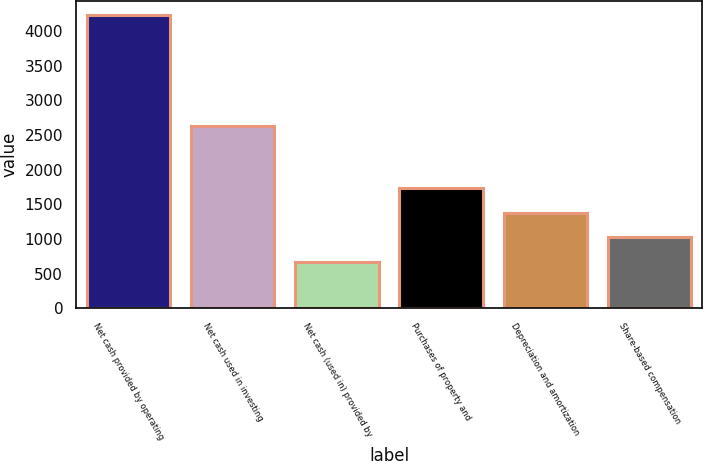Convert chart. <chart><loc_0><loc_0><loc_500><loc_500><bar_chart><fcel>Net cash provided by operating<fcel>Net cash used in investing<fcel>Net cash (used in) provided by<fcel>Purchases of property and<fcel>Depreciation and amortization<fcel>Share-based compensation<nl><fcel>4222<fcel>2624<fcel>667<fcel>1733.5<fcel>1378<fcel>1022.5<nl></chart> 